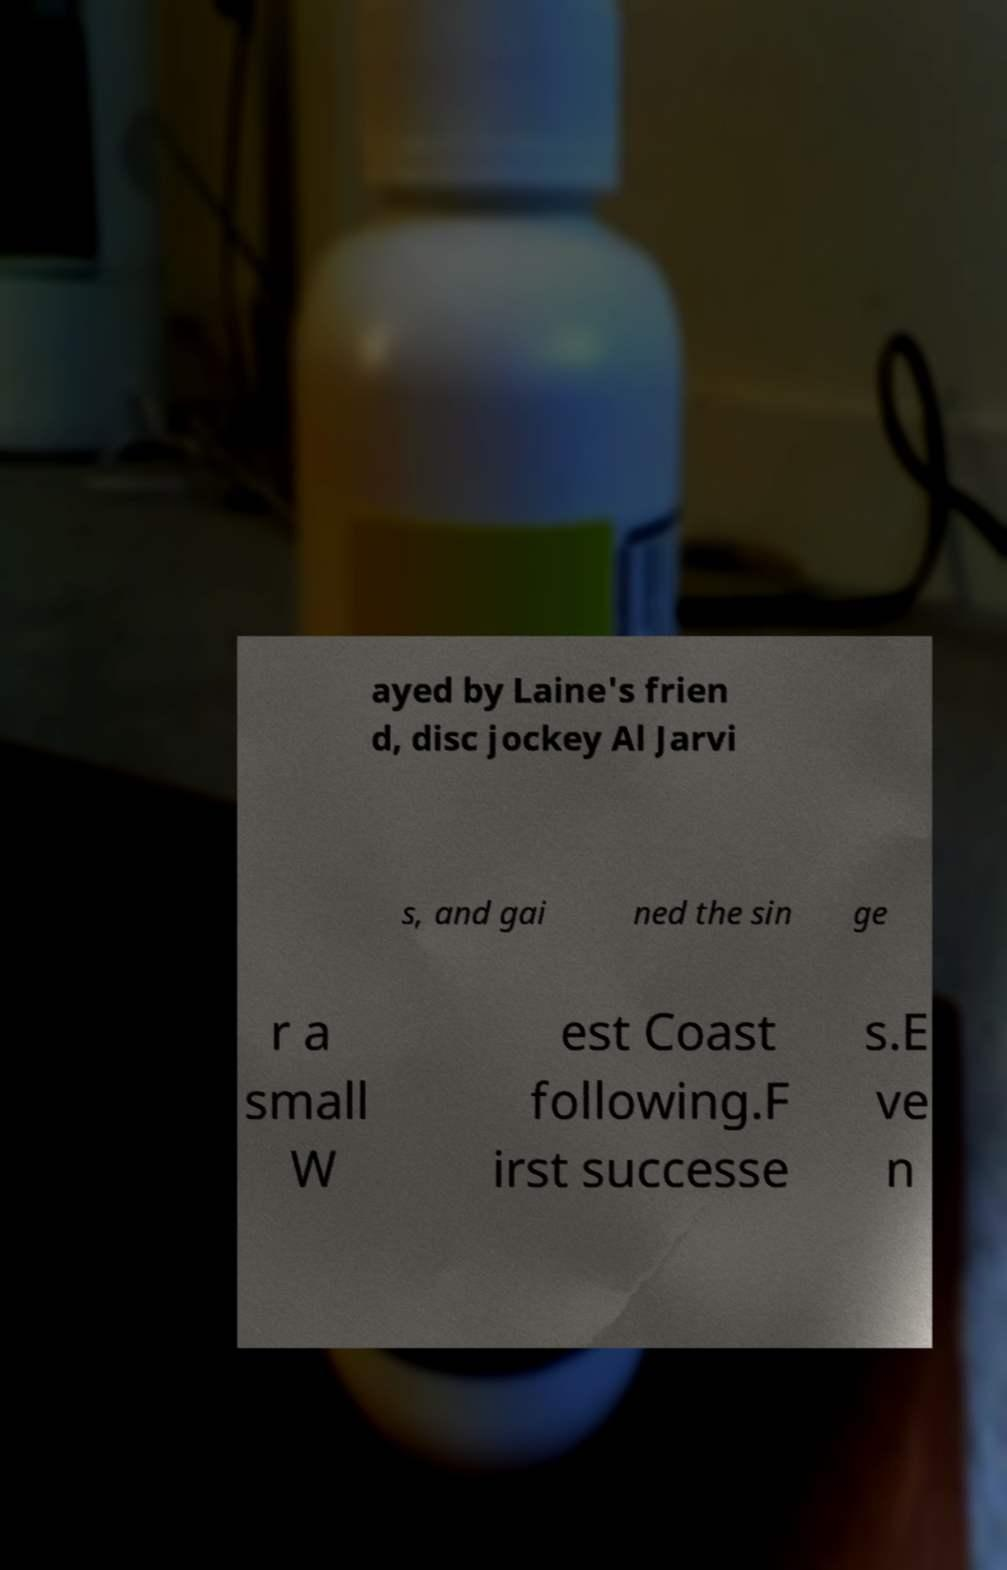Can you accurately transcribe the text from the provided image for me? ayed by Laine's frien d, disc jockey Al Jarvi s, and gai ned the sin ge r a small W est Coast following.F irst successe s.E ve n 